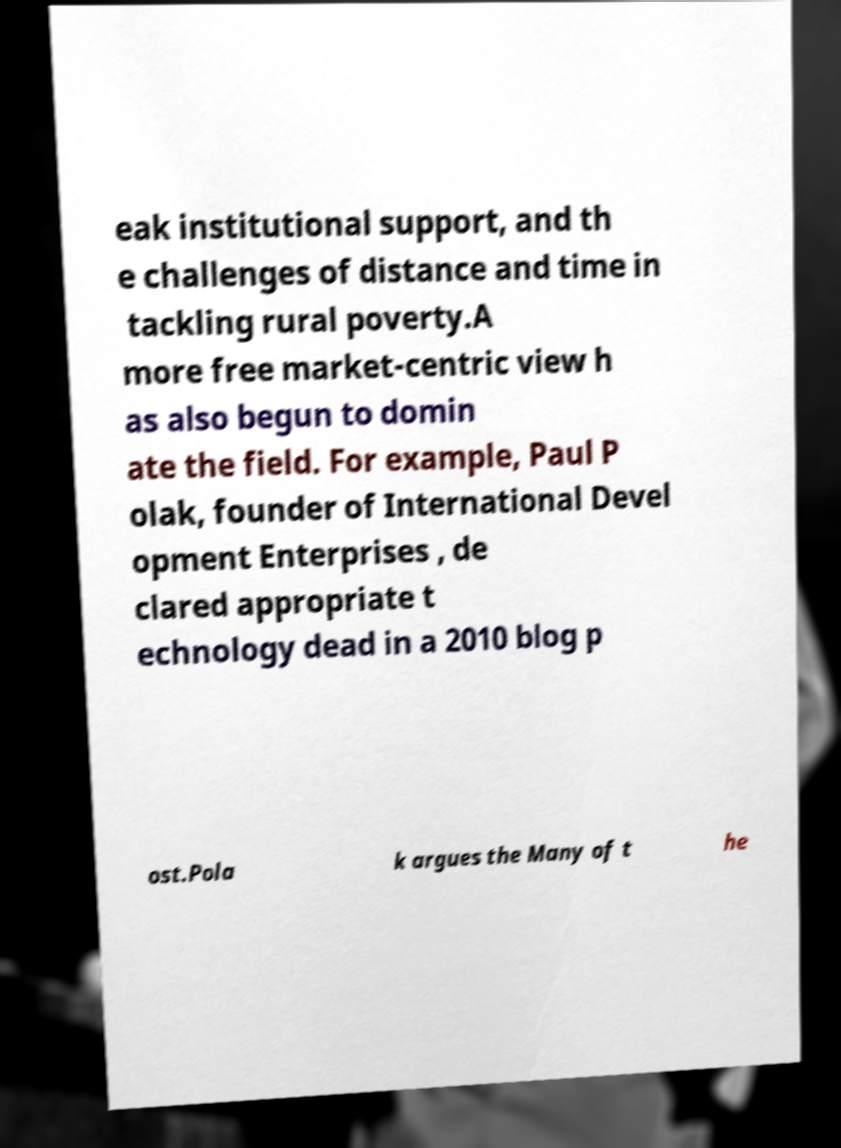What messages or text are displayed in this image? I need them in a readable, typed format. eak institutional support, and th e challenges of distance and time in tackling rural poverty.A more free market-centric view h as also begun to domin ate the field. For example, Paul P olak, founder of International Devel opment Enterprises , de clared appropriate t echnology dead in a 2010 blog p ost.Pola k argues the Many of t he 